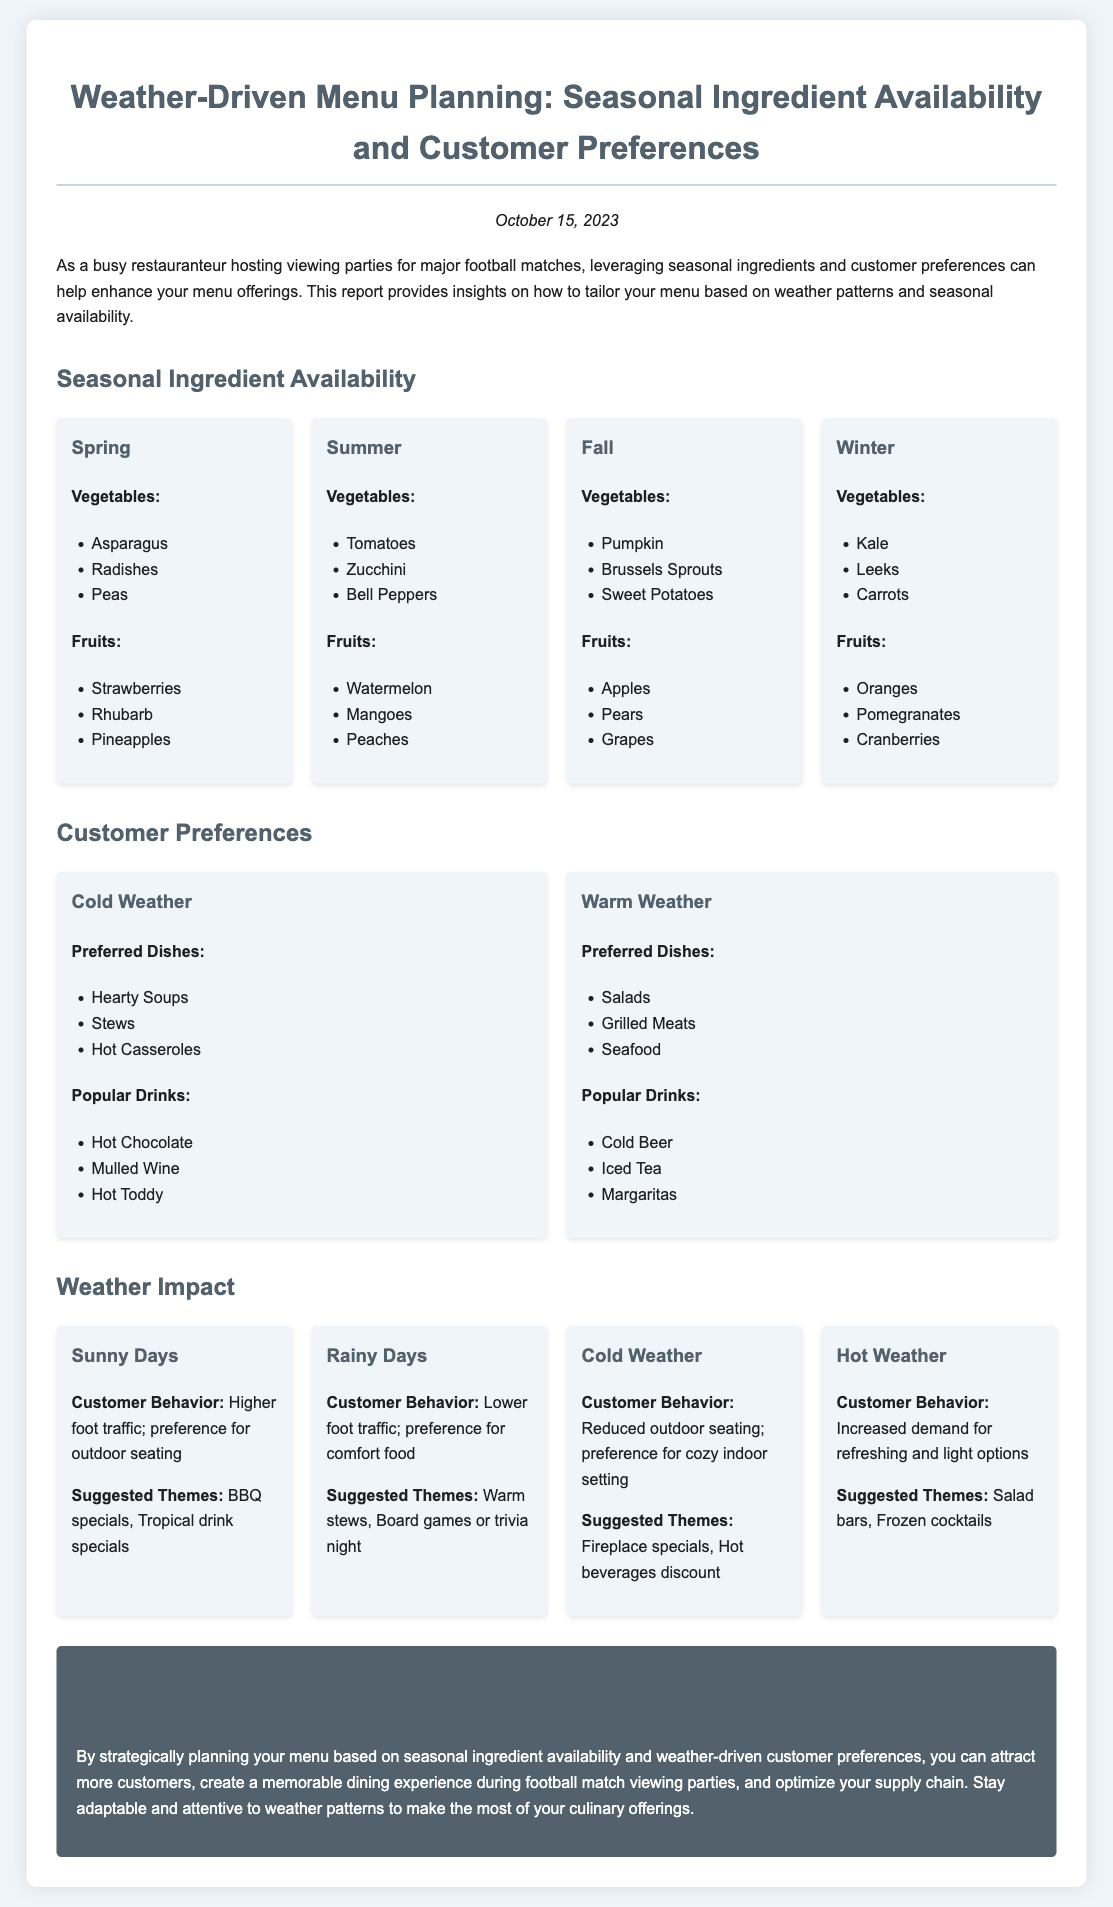What vegetables are available in Spring? Spring vegetables listed are Asparagus, Radishes, and Peas.
Answer: Asparagus, Radishes, Peas What is a popular drink preference during warm weather? The document mentions Cold Beer, Iced Tea, and Margaritas as popular drinks in warm weather.
Answer: Cold Beer What are the suggested themes for rainy days? The report suggests Warm stews and Board games or trivia night as themes for rainy days.
Answer: Warm stews, Board games or trivia night Which fruit is listed under Winter seasonal availability? The report lists Oranges, Pomegranates, and Cranberries for Winter fruit availability.
Answer: Oranges What is the expected customer behavior during sunny days? Customer behavior during sunny days includes higher foot traffic and preference for outdoor seating.
Answer: Higher foot traffic; preference for outdoor seating What type of dishes do customers prefer in cold weather? In cold weather, preferred dishes include Hearty Soups, Stews, and Hot Casseroles.
Answer: Hearty Soups, Stews, Hot Casseroles What season is associated with the availability of Strawberries? The report classifies Strawberries as a Spring fruit.
Answer: Spring What is the conclusion of the report? The conclusion highlights the importance of planning menus based on seasonal and weather-driven customer preferences.
Answer: Strategic menu planning based on seasonal availability and customer preferences 